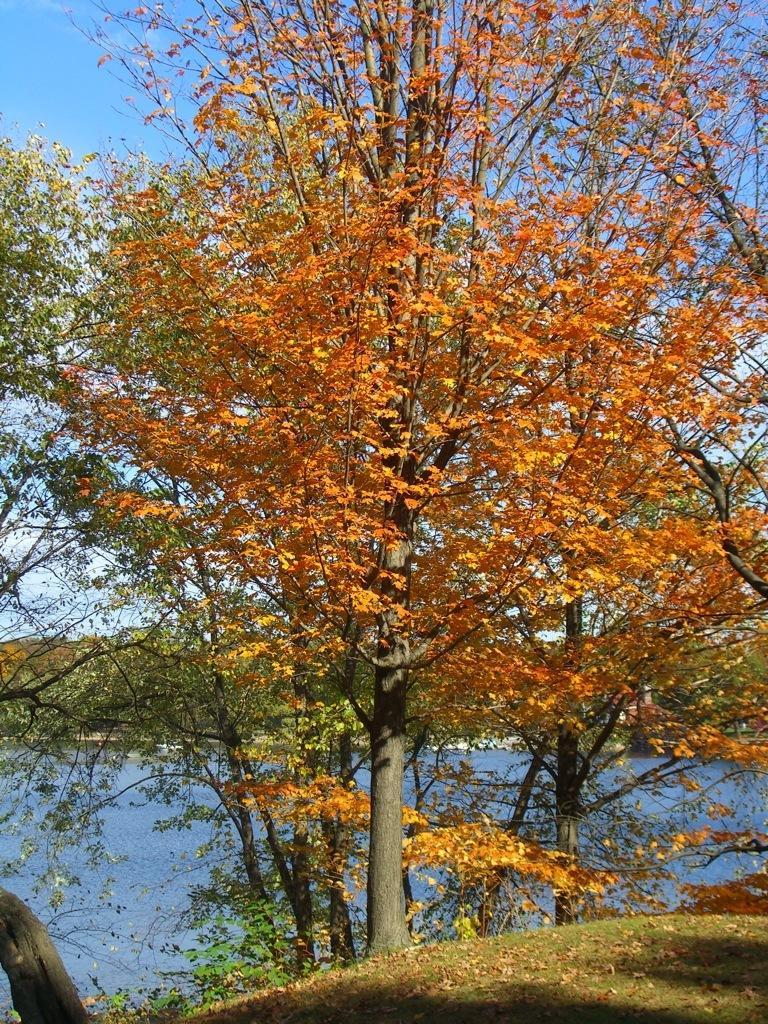How would you summarize this image in a sentence or two? In the center of the image there are trees. In the background we can see a lake, hills and sky. At the bottom there is grass. 